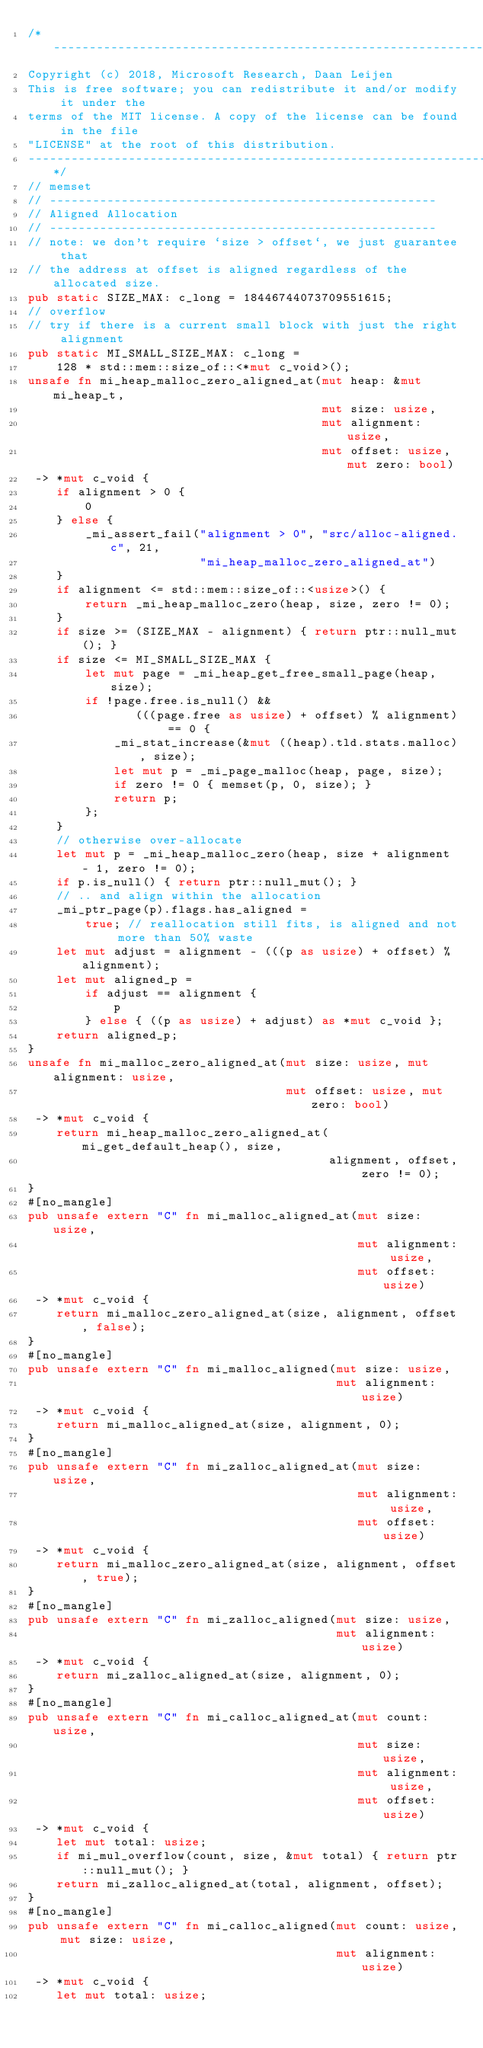Convert code to text. <code><loc_0><loc_0><loc_500><loc_500><_Rust_>/* ----------------------------------------------------------------------------
Copyright (c) 2018, Microsoft Research, Daan Leijen
This is free software; you can redistribute it and/or modify it under the
terms of the MIT license. A copy of the license can be found in the file
"LICENSE" at the root of this distribution.
-----------------------------------------------------------------------------*/
// memset
// ------------------------------------------------------
// Aligned Allocation
// ------------------------------------------------------
// note: we don't require `size > offset`, we just guarantee that
// the address at offset is aligned regardless of the allocated size.
pub static SIZE_MAX: c_long = 18446744073709551615;
// overflow
// try if there is a current small block with just the right alignment
pub static MI_SMALL_SIZE_MAX: c_long =
    128 * std::mem::size_of::<*mut c_void>();
unsafe fn mi_heap_malloc_zero_aligned_at(mut heap: &mut mi_heap_t,
                                         mut size: usize,
                                         mut alignment: usize,
                                         mut offset: usize, mut zero: bool)
 -> *mut c_void {
    if alignment > 0 {
        0
    } else {
        _mi_assert_fail("alignment > 0", "src/alloc-aligned.c", 21,
                        "mi_heap_malloc_zero_aligned_at")
    }
    if alignment <= std::mem::size_of::<usize>() {
        return _mi_heap_malloc_zero(heap, size, zero != 0);
    }
    if size >= (SIZE_MAX - alignment) { return ptr::null_mut(); }
    if size <= MI_SMALL_SIZE_MAX {
        let mut page = _mi_heap_get_free_small_page(heap, size);
        if !page.free.is_null() &&
               (((page.free as usize) + offset) % alignment) == 0 {
            _mi_stat_increase(&mut ((heap).tld.stats.malloc), size);
            let mut p = _mi_page_malloc(heap, page, size);
            if zero != 0 { memset(p, 0, size); }
            return p;
        };
    }
    // otherwise over-allocate
    let mut p = _mi_heap_malloc_zero(heap, size + alignment - 1, zero != 0);
    if p.is_null() { return ptr::null_mut(); }
    // .. and align within the allocation
    _mi_ptr_page(p).flags.has_aligned =
        true; // reallocation still fits, is aligned and not more than 50% waste
    let mut adjust = alignment - (((p as usize) + offset) % alignment);
    let mut aligned_p =
        if adjust == alignment {
            p
        } else { ((p as usize) + adjust) as *mut c_void };
    return aligned_p;
}
unsafe fn mi_malloc_zero_aligned_at(mut size: usize, mut alignment: usize,
                                    mut offset: usize, mut zero: bool)
 -> *mut c_void {
    return mi_heap_malloc_zero_aligned_at(mi_get_default_heap(), size,
                                          alignment, offset, zero != 0);
}
#[no_mangle]
pub unsafe extern "C" fn mi_malloc_aligned_at(mut size: usize,
                                              mut alignment: usize,
                                              mut offset: usize)
 -> *mut c_void {
    return mi_malloc_zero_aligned_at(size, alignment, offset, false);
}
#[no_mangle]
pub unsafe extern "C" fn mi_malloc_aligned(mut size: usize,
                                           mut alignment: usize)
 -> *mut c_void {
    return mi_malloc_aligned_at(size, alignment, 0);
}
#[no_mangle]
pub unsafe extern "C" fn mi_zalloc_aligned_at(mut size: usize,
                                              mut alignment: usize,
                                              mut offset: usize)
 -> *mut c_void {
    return mi_malloc_zero_aligned_at(size, alignment, offset, true);
}
#[no_mangle]
pub unsafe extern "C" fn mi_zalloc_aligned(mut size: usize,
                                           mut alignment: usize)
 -> *mut c_void {
    return mi_zalloc_aligned_at(size, alignment, 0);
}
#[no_mangle]
pub unsafe extern "C" fn mi_calloc_aligned_at(mut count: usize,
                                              mut size: usize,
                                              mut alignment: usize,
                                              mut offset: usize)
 -> *mut c_void {
    let mut total: usize;
    if mi_mul_overflow(count, size, &mut total) { return ptr::null_mut(); }
    return mi_zalloc_aligned_at(total, alignment, offset);
}
#[no_mangle]
pub unsafe extern "C" fn mi_calloc_aligned(mut count: usize, mut size: usize,
                                           mut alignment: usize)
 -> *mut c_void {
    let mut total: usize;</code> 